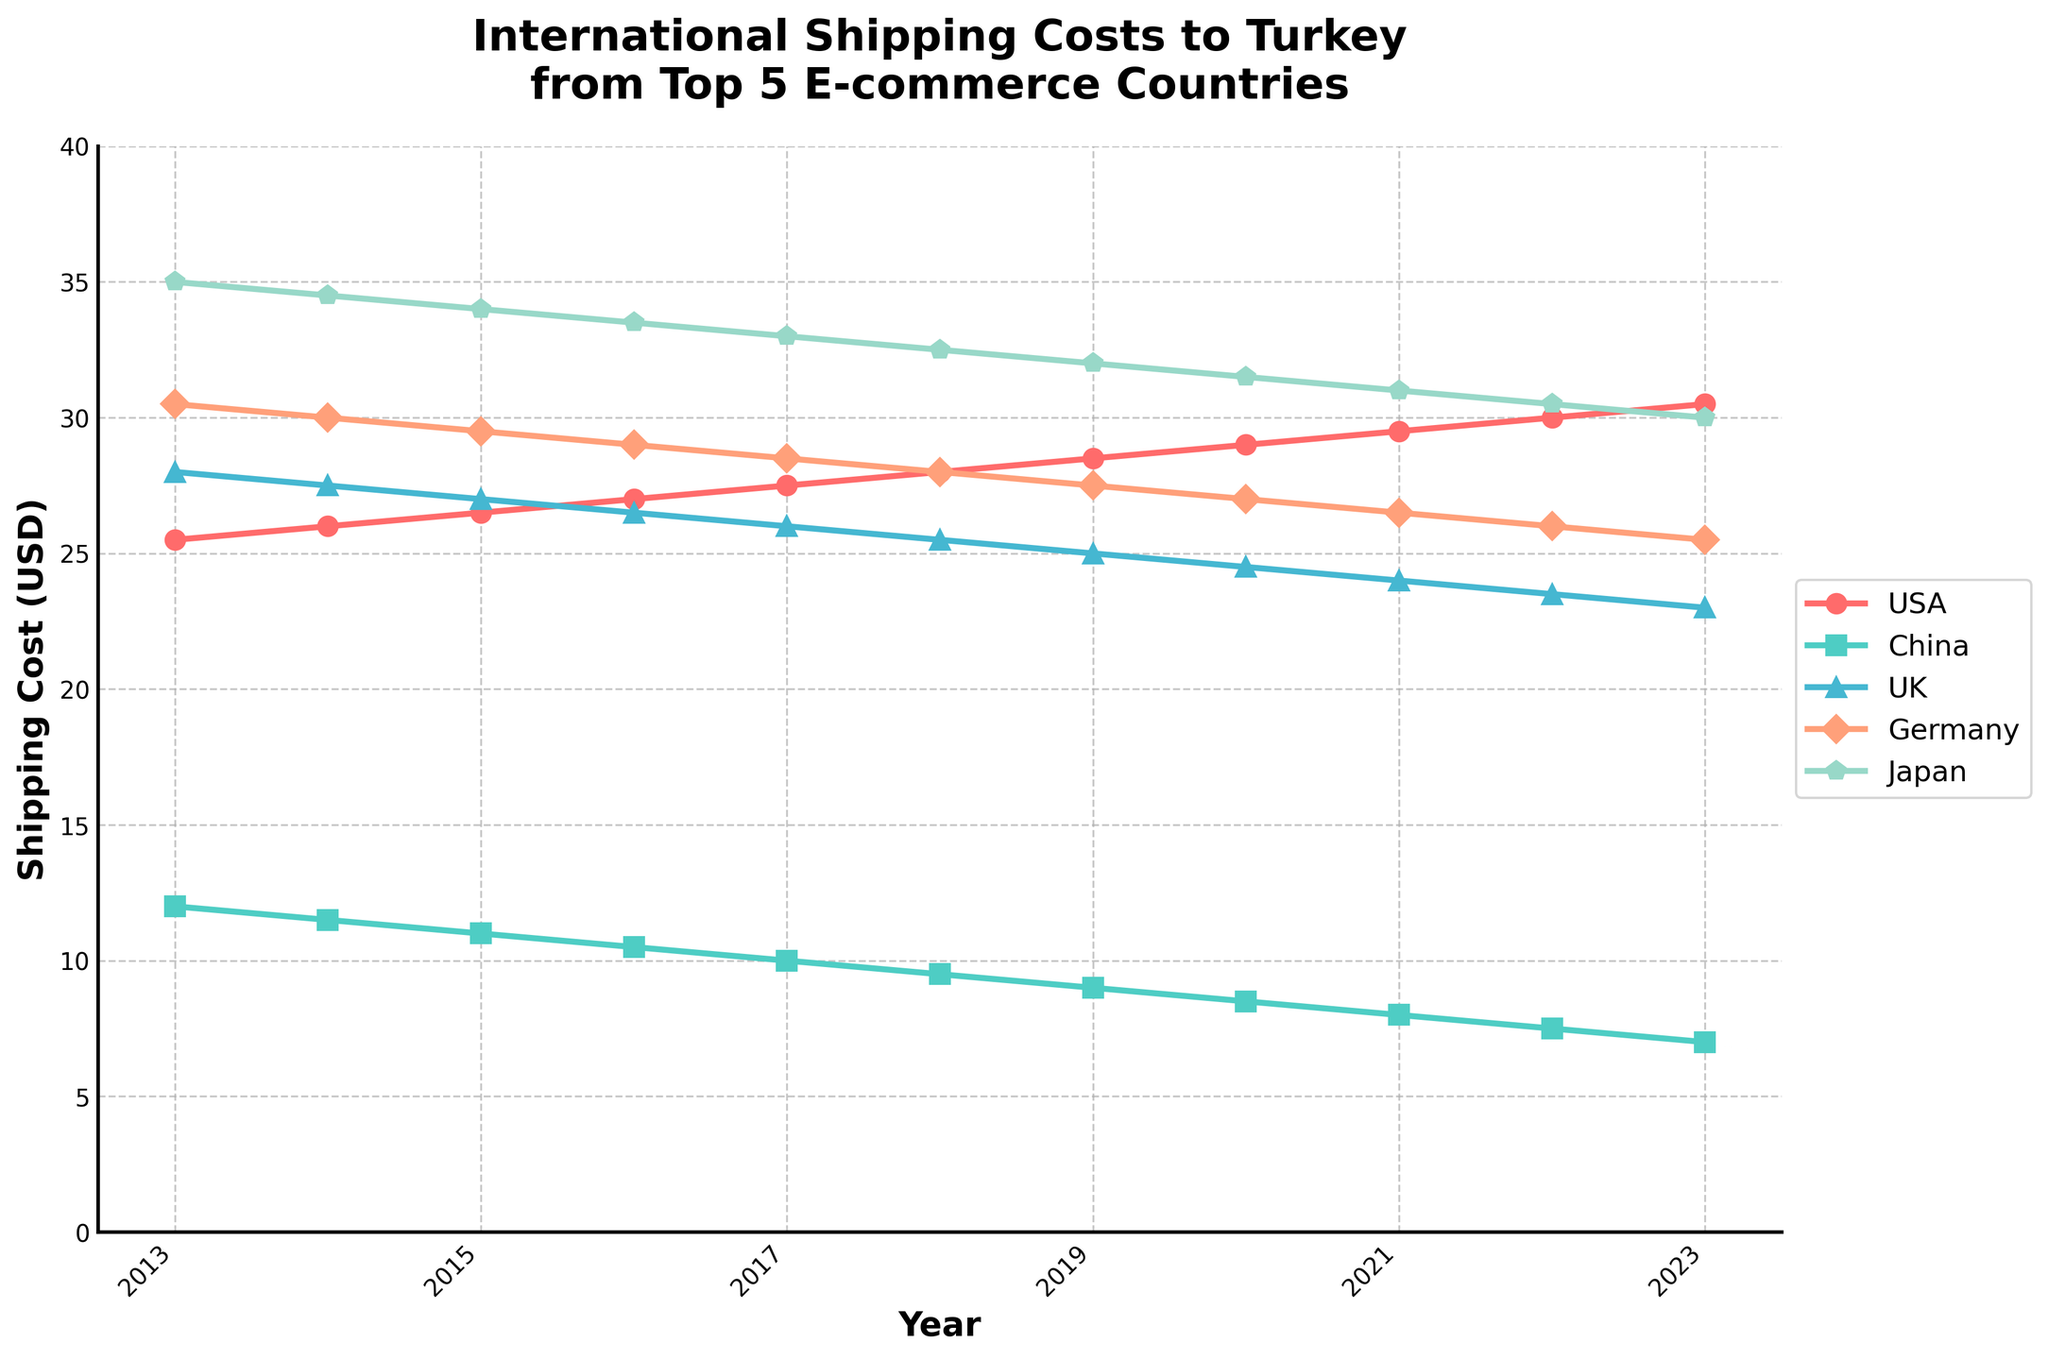Which country has shown the largest decrease in shipping costs over the last decade? To determine this, we need to look at the changes in shipping costs from 2013 to 2023 for each country. Subtract the cost in 2023 from the cost in 2013 for each country. The country with the greatest difference has the largest decrease. China's shipping cost went from $12.00 to $7.00, a difference of $5.00.
Answer: China Which year did the UK have the highest shipping cost, and what was it? Looking at the line representing the UK, the highest point corresponds to the year 2013. The shipping cost in that year was $28.00.
Answer: 2013, $28.00 What is the average shipping cost from the USA over the last decade? To calculate the average, sum all the annual shipping costs from the USA from 2013 to 2023, then divide by the number of years (11). The sum is $264.00, so the average is $264.00/11 = $24.00.
Answer: $24.00 In which year did Germany's shipping cost first drop below $30? By observing the line for Germany, the first time it drops below $30 is in 2018 when it reached $28.00.
Answer: 2018 Which country had the highest shipping cost in 2023 and what was it? Looking at the values for 2023, Japan has the highest shipping cost at $30.00.
Answer: Japan, $30.00 What is the trend of shipping costs from China over the decade? The line for China shows a consistent and steady decline from $12.00 in 2013 to $7.00 in 2023.
Answer: Steady decline In which years did the shipping cost from Japan remain unchanged? Observe if there are any flat lines in Japan’s plot. From 2013 to 2015 and from 2022 to 2023, the cost remained unchanged, at $35.00 and $30.00 respectively.
Answer: 2013-2015, 2022-2023 For which country did shipping costs decrease the most between 2018 and 2023? Calculate the change for each country between 2018 and 2023: USA (+2.50), China (-2.50), UK (-2.50), Germany (-2.50), Japan (-2.50). All countries except the USA experienced a decrease of $2.50.
Answer: China, UK, Germany, Japan What was the difference in shipping costs between the USA and Japan in 2015? Subtract the cost for Japan in 2015 ($34.00) from the cost for the USA in 2015 ($26.50). The difference is $34.00 - $26.50 = $7.50.
Answer: $7.50 Which country showed the most stable shipping cost over the decade? By visual inspection, the USA shows a relatively stable trend with gradual increases compared to other countries with more significant fluctuations.
Answer: USA 